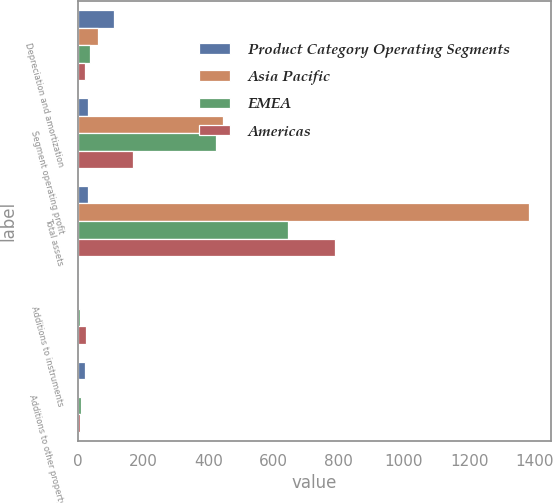<chart> <loc_0><loc_0><loc_500><loc_500><stacked_bar_chart><ecel><fcel>Depreciation and amortization<fcel>Segment operating profit<fcel>Total assets<fcel>Additions to instruments<fcel>Additions to other property<nl><fcel>Product Category Operating Segments<fcel>110<fcel>30.35<fcel>30.35<fcel>1.6<fcel>21.7<nl><fcel>Asia Pacific<fcel>61.1<fcel>445.3<fcel>1382.2<fcel>0.2<fcel>3.4<nl><fcel>EMEA<fcel>37.9<fcel>421.9<fcel>642.4<fcel>4.7<fcel>9<nl><fcel>Americas<fcel>21<fcel>167.9<fcel>788.3<fcel>22.8<fcel>4.6<nl></chart> 